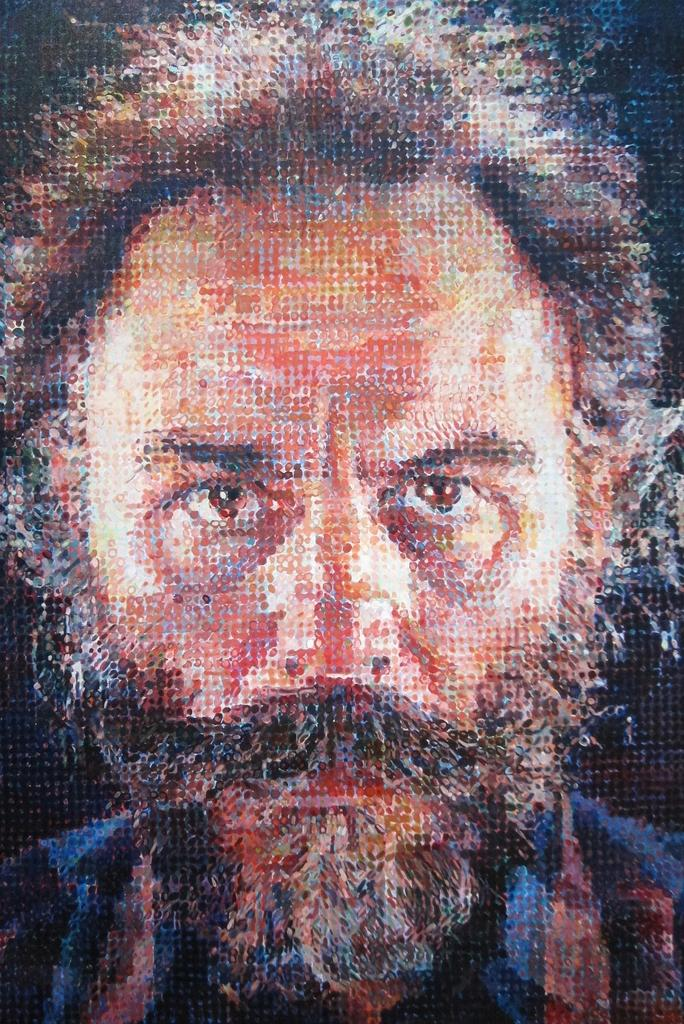Who is the main subject in the image? There is a man in the image. Can you describe the man's position in the image? The man is standing in the front. What is the man doing in the image? The man is looking at the camera. Has the image been altered in any way? Yes, the image has been edited. What type of juice is the squirrel drinking in the image? There is no squirrel or juice present in the image; it features a man standing in the front and looking at the camera. 